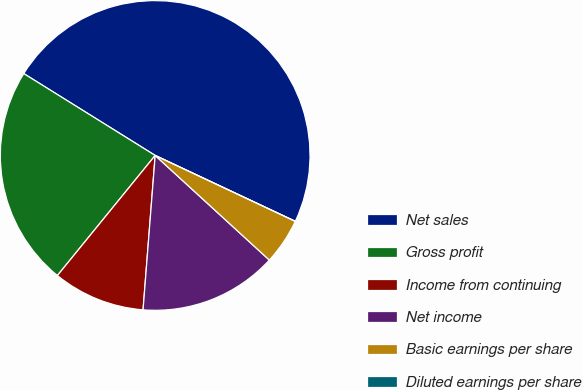Convert chart. <chart><loc_0><loc_0><loc_500><loc_500><pie_chart><fcel>Net sales<fcel>Gross profit<fcel>Income from continuing<fcel>Net income<fcel>Basic earnings per share<fcel>Diluted earnings per share<nl><fcel>48.13%<fcel>22.99%<fcel>9.63%<fcel>14.44%<fcel>4.81%<fcel>0.0%<nl></chart> 